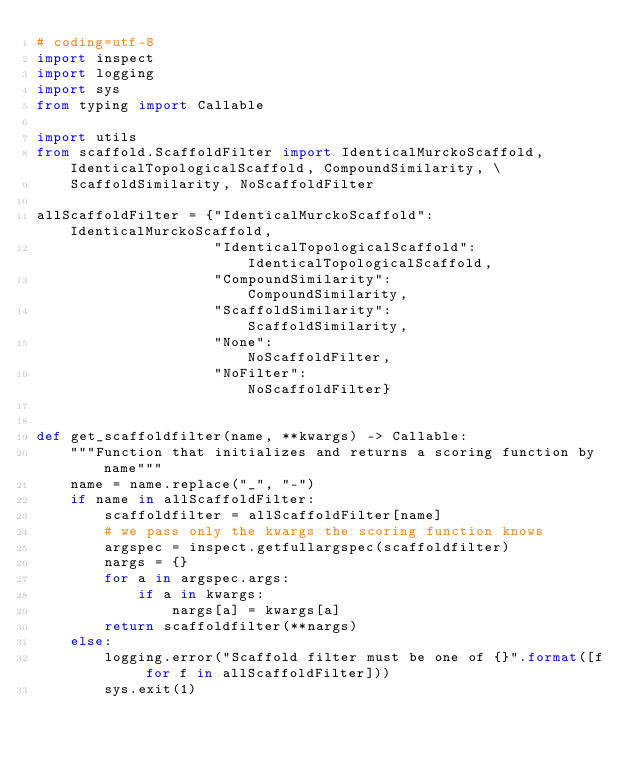<code> <loc_0><loc_0><loc_500><loc_500><_Python_># coding=utf-8
import inspect
import logging
import sys
from typing import Callable

import utils
from scaffold.ScaffoldFilter import IdenticalMurckoScaffold, IdenticalTopologicalScaffold, CompoundSimilarity, \
    ScaffoldSimilarity, NoScaffoldFilter

allScaffoldFilter = {"IdenticalMurckoScaffold":      IdenticalMurckoScaffold,
                     "IdenticalTopologicalScaffold": IdenticalTopologicalScaffold,
                     "CompoundSimilarity":           CompoundSimilarity,
                     "ScaffoldSimilarity":           ScaffoldSimilarity,
                     "None":                         NoScaffoldFilter,
                     "NoFilter":                     NoScaffoldFilter}


def get_scaffoldfilter(name, **kwargs) -> Callable:
    """Function that initializes and returns a scoring function by name"""
    name = name.replace("_", "-")
    if name in allScaffoldFilter:
        scaffoldfilter = allScaffoldFilter[name]
        # we pass only the kwargs the scoring function knows
        argspec = inspect.getfullargspec(scaffoldfilter)
        nargs = {}
        for a in argspec.args:
            if a in kwargs:
                nargs[a] = kwargs[a]
        return scaffoldfilter(**nargs)
    else:
        logging.error("Scaffold filter must be one of {}".format([f for f in allScaffoldFilter]))
        sys.exit(1)

</code> 